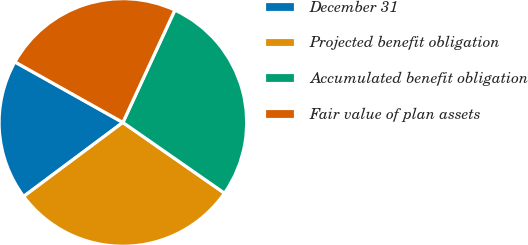Convert chart. <chart><loc_0><loc_0><loc_500><loc_500><pie_chart><fcel>December 31<fcel>Projected benefit obligation<fcel>Accumulated benefit obligation<fcel>Fair value of plan assets<nl><fcel>18.33%<fcel>30.12%<fcel>27.78%<fcel>23.76%<nl></chart> 